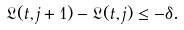Convert formula to latex. <formula><loc_0><loc_0><loc_500><loc_500>\mathfrak { L } ( t , j + 1 ) - \mathfrak { L } ( t , j ) \leq - \delta .</formula> 